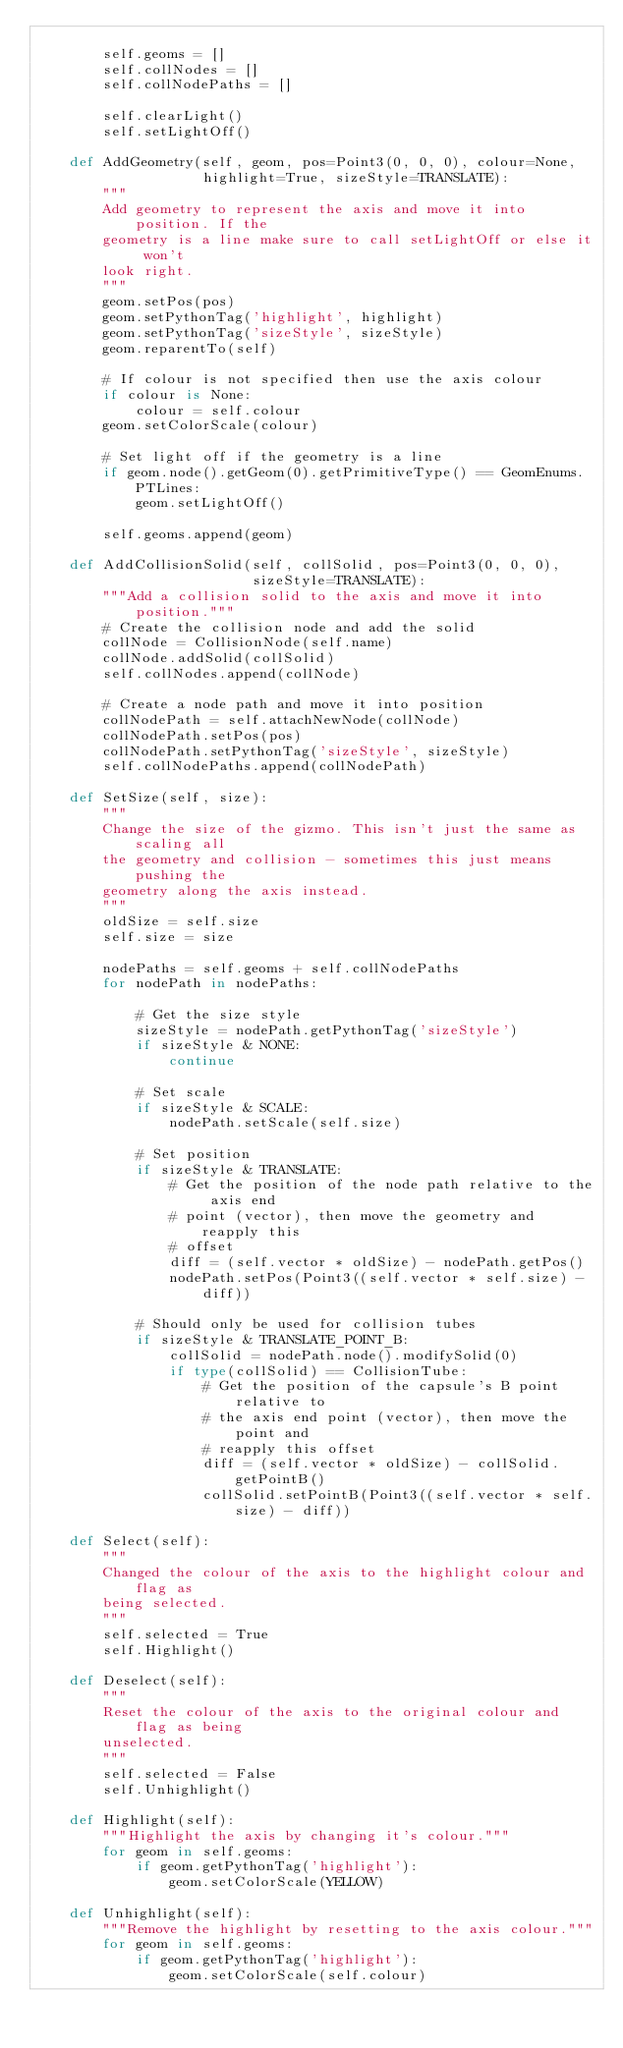<code> <loc_0><loc_0><loc_500><loc_500><_Python_>
        self.geoms = []
        self.collNodes = []
        self.collNodePaths = []

        self.clearLight()
        self.setLightOff()

    def AddGeometry(self, geom, pos=Point3(0, 0, 0), colour=None,
                    highlight=True, sizeStyle=TRANSLATE):
        """
        Add geometry to represent the axis and move it into position. If the
        geometry is a line make sure to call setLightOff or else it won't
        look right.
        """
        geom.setPos(pos)
        geom.setPythonTag('highlight', highlight)
        geom.setPythonTag('sizeStyle', sizeStyle)
        geom.reparentTo(self)

        # If colour is not specified then use the axis colour
        if colour is None:
            colour = self.colour
        geom.setColorScale(colour)

        # Set light off if the geometry is a line
        if geom.node().getGeom(0).getPrimitiveType() == GeomEnums.PTLines:
            geom.setLightOff()

        self.geoms.append(geom)

    def AddCollisionSolid(self, collSolid, pos=Point3(0, 0, 0),
                          sizeStyle=TRANSLATE):
        """Add a collision solid to the axis and move it into position."""
        # Create the collision node and add the solid
        collNode = CollisionNode(self.name)
        collNode.addSolid(collSolid)
        self.collNodes.append(collNode)

        # Create a node path and move it into position
        collNodePath = self.attachNewNode(collNode)
        collNodePath.setPos(pos)
        collNodePath.setPythonTag('sizeStyle', sizeStyle)
        self.collNodePaths.append(collNodePath)

    def SetSize(self, size):
        """
        Change the size of the gizmo. This isn't just the same as scaling all
        the geometry and collision - sometimes this just means pushing the
        geometry along the axis instead.
        """
        oldSize = self.size
        self.size = size

        nodePaths = self.geoms + self.collNodePaths
        for nodePath in nodePaths:

            # Get the size style
            sizeStyle = nodePath.getPythonTag('sizeStyle')
            if sizeStyle & NONE:
                continue

            # Set scale
            if sizeStyle & SCALE:
                nodePath.setScale(self.size)

            # Set position
            if sizeStyle & TRANSLATE:
                # Get the position of the node path relative to the axis end
                # point (vector), then move the geometry and reapply this
                # offset 
                diff = (self.vector * oldSize) - nodePath.getPos()
                nodePath.setPos(Point3((self.vector * self.size) - diff))

            # Should only be used for collision tubes
            if sizeStyle & TRANSLATE_POINT_B:
                collSolid = nodePath.node().modifySolid(0)
                if type(collSolid) == CollisionTube:
                    # Get the position of the capsule's B point relative to
                    # the axis end point (vector), then move the point and
                    # reapply this offset 
                    diff = (self.vector * oldSize) - collSolid.getPointB()
                    collSolid.setPointB(Point3((self.vector * self.size) - diff))

    def Select(self):
        """
        Changed the colour of the axis to the highlight colour and flag as
        being selected.
        """
        self.selected = True
        self.Highlight()

    def Deselect(self):
        """
        Reset the colour of the axis to the original colour and flag as being
        unselected.
        """
        self.selected = False
        self.Unhighlight()

    def Highlight(self):
        """Highlight the axis by changing it's colour."""
        for geom in self.geoms:
            if geom.getPythonTag('highlight'):
                geom.setColorScale(YELLOW)

    def Unhighlight(self):
        """Remove the highlight by resetting to the axis colour."""
        for geom in self.geoms:
            if geom.getPythonTag('highlight'):
                geom.setColorScale(self.colour)
</code> 